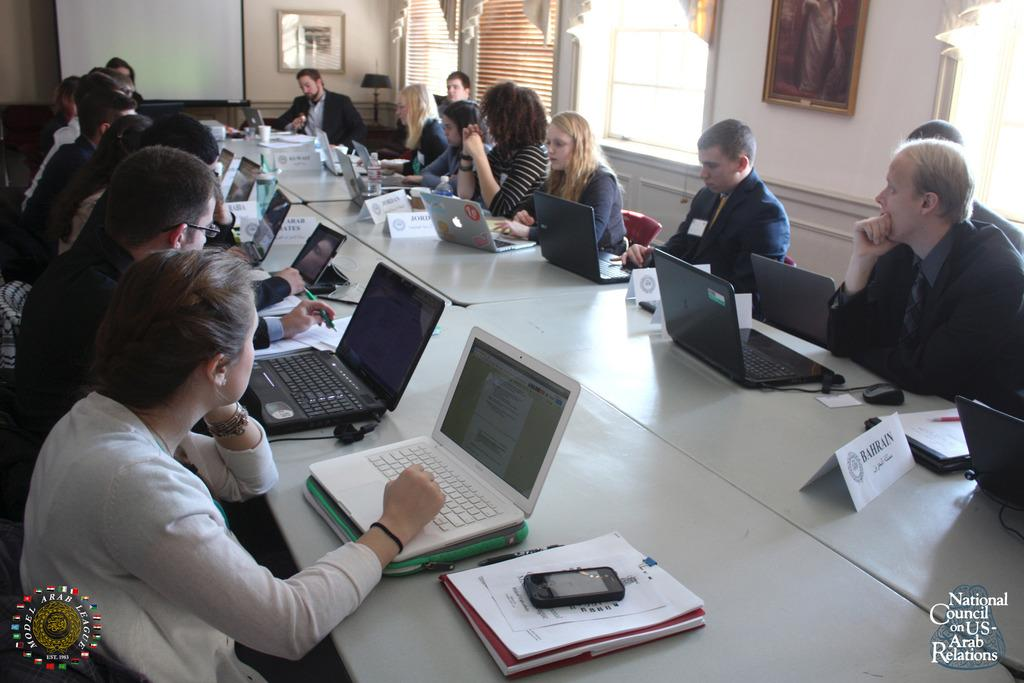Provide a one-sentence caption for the provided image. The National Council on US-Arab Relations gathers in a conference room with laptops in front of them. 